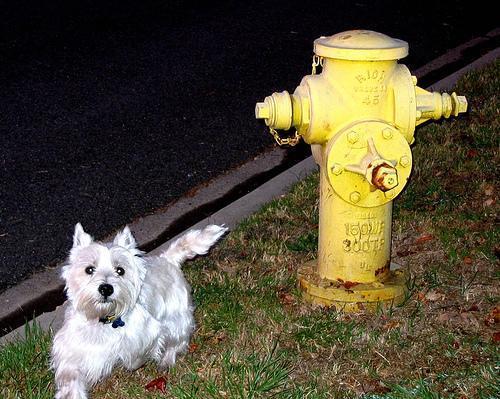How many dogs are there?
Give a very brief answer. 1. 